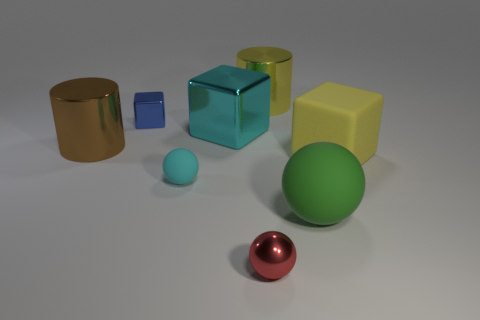Subtract all matte blocks. How many blocks are left? 2 Subtract 1 blocks. How many blocks are left? 2 Add 1 big gray cylinders. How many objects exist? 9 Subtract all cylinders. How many objects are left? 6 Subtract all small metallic things. Subtract all small cyan matte balls. How many objects are left? 5 Add 1 red metal balls. How many red metal balls are left? 2 Add 6 purple objects. How many purple objects exist? 6 Subtract 0 purple cylinders. How many objects are left? 8 